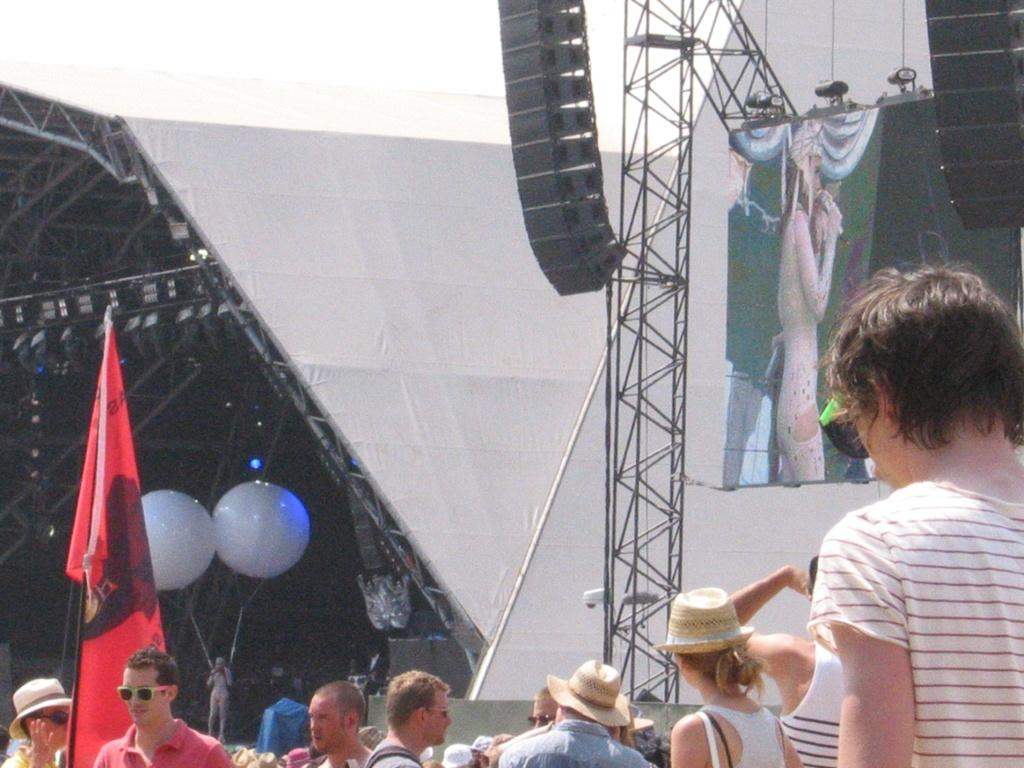How many people are in the group in the image? There is a group of people in the image, but the exact number is not specified. What protective gear are some people wearing in the group? Some people in the group are wearing goggles. What headgear are some people wearing in the group? Some people in the group are wearing caps. What decorative items can be seen in the image? There are flags, balloons, and lights in the image. What equipment can be seen in the image? There are rods in the image. What additional objects can be seen in the image? There are other objects in the image, but their specific nature is not described. What type of lip balm is being used by the person with the knee injury in the image? There is no mention of a person with a knee injury or lip balm in the image. 